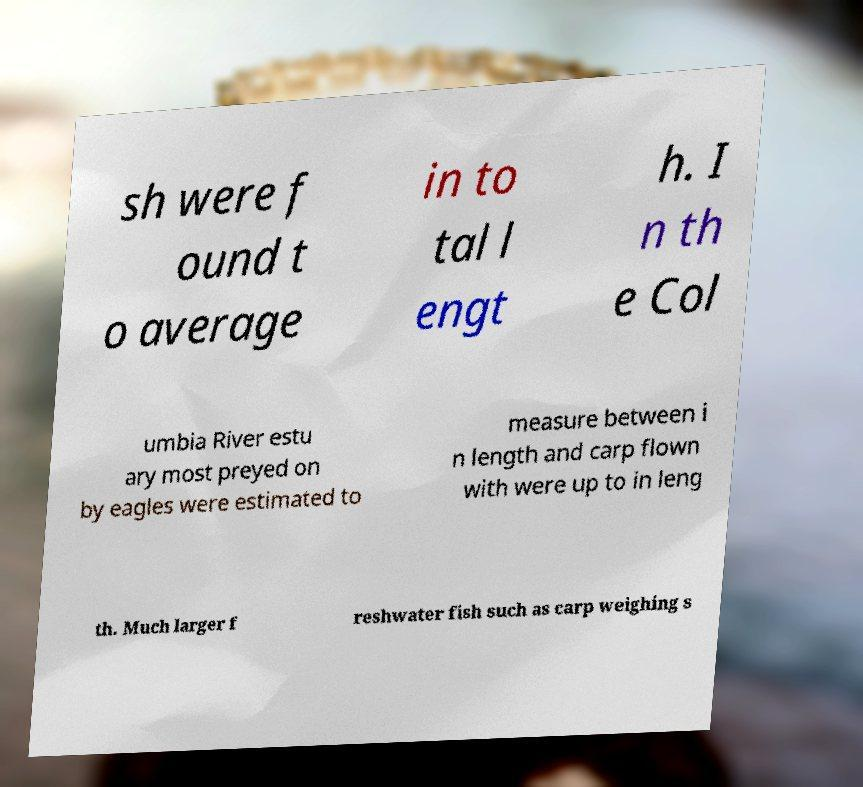Could you extract and type out the text from this image? sh were f ound t o average in to tal l engt h. I n th e Col umbia River estu ary most preyed on by eagles were estimated to measure between i n length and carp flown with were up to in leng th. Much larger f reshwater fish such as carp weighing s 